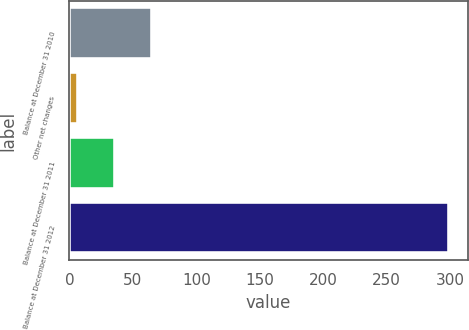<chart> <loc_0><loc_0><loc_500><loc_500><bar_chart><fcel>Balance at December 31 2010<fcel>Other net changes<fcel>Balance at December 31 2011<fcel>Balance at December 31 2012<nl><fcel>65.4<fcel>7<fcel>36.2<fcel>299<nl></chart> 